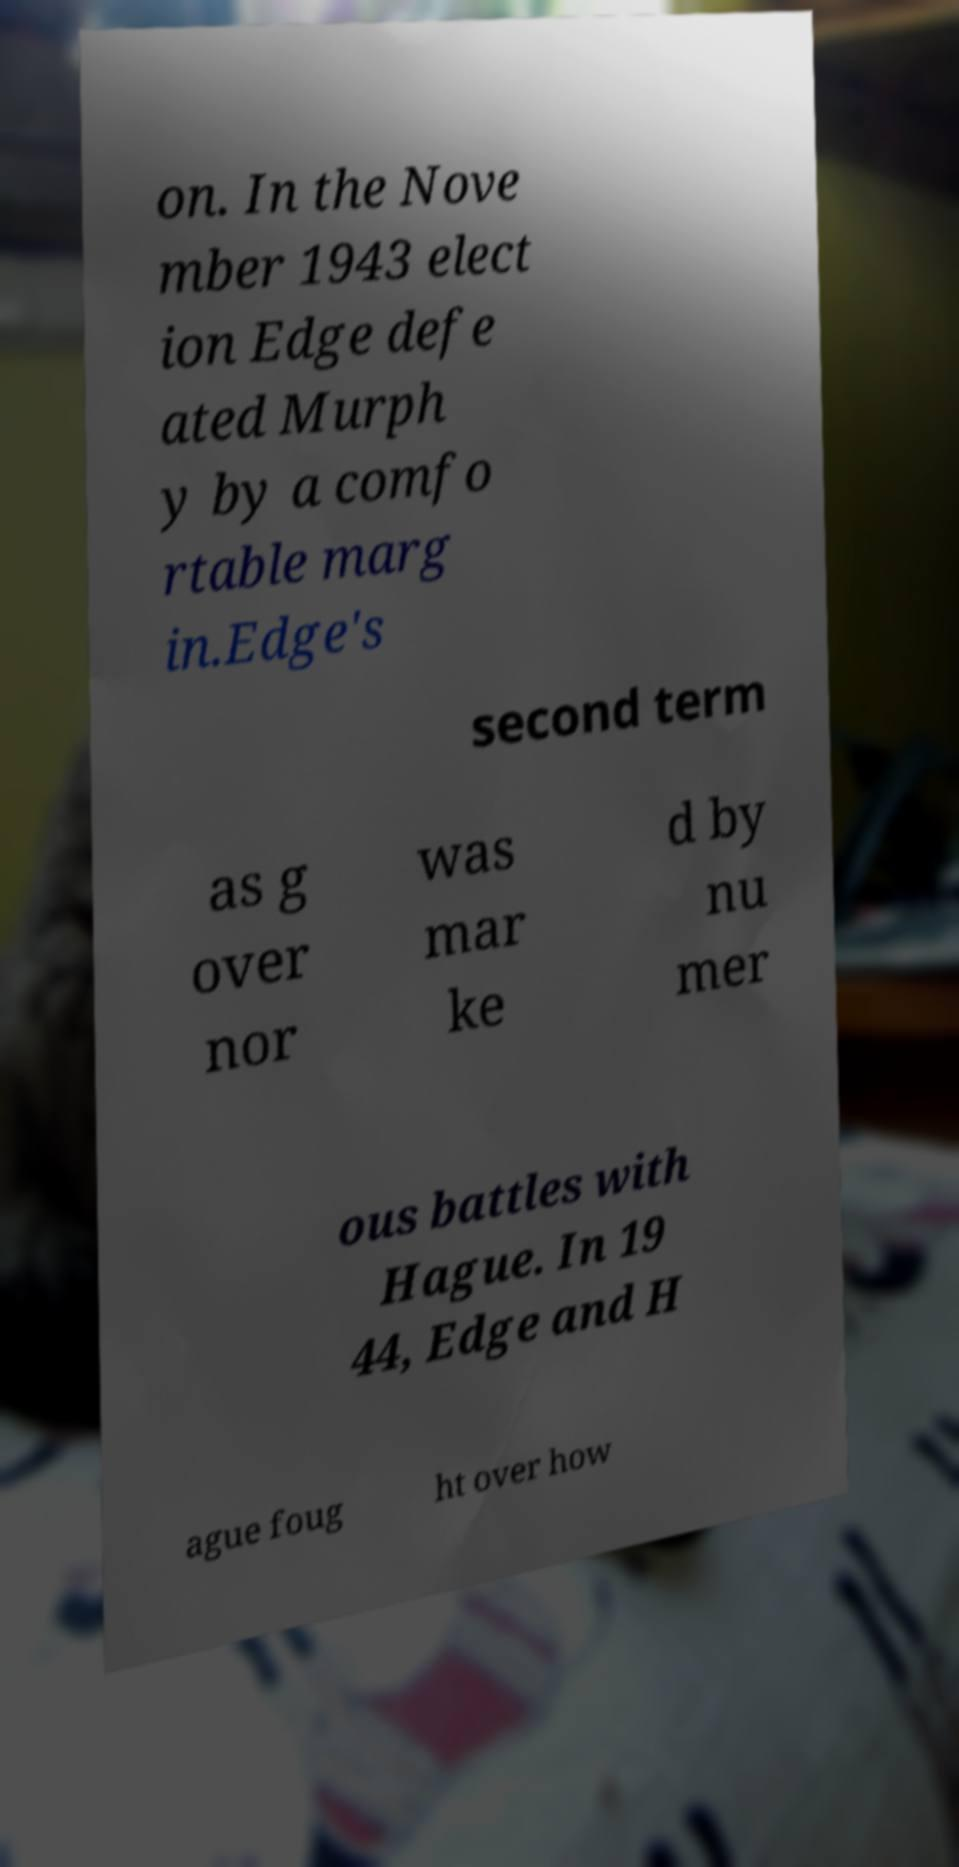Please read and relay the text visible in this image. What does it say? on. In the Nove mber 1943 elect ion Edge defe ated Murph y by a comfo rtable marg in.Edge's second term as g over nor was mar ke d by nu mer ous battles with Hague. In 19 44, Edge and H ague foug ht over how 